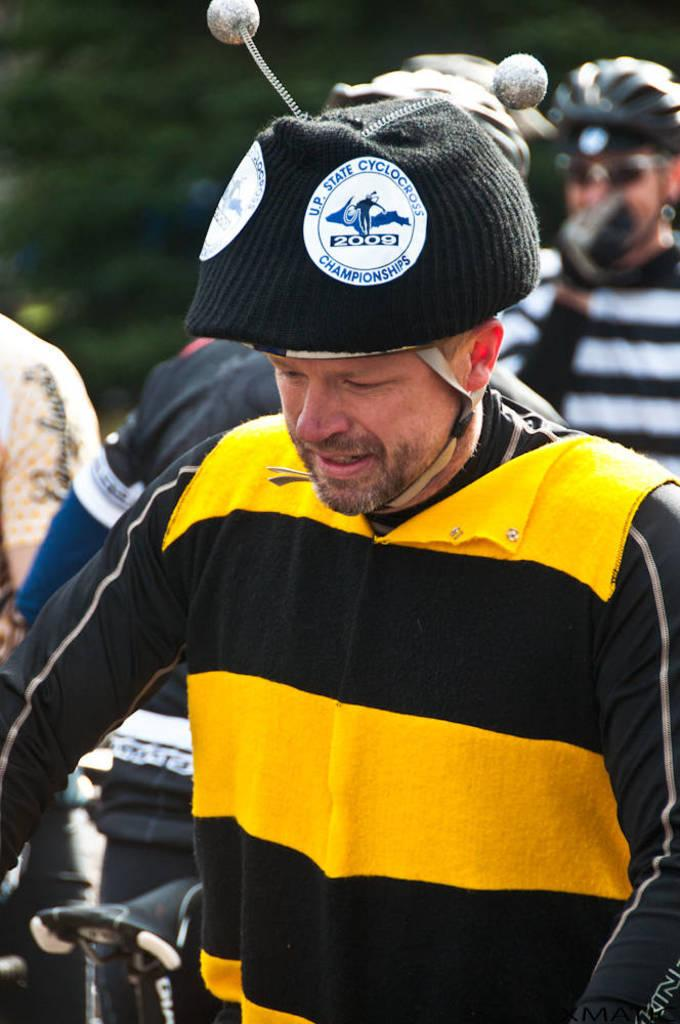How many people are in the image? There is a group of people in the image, but the exact number cannot be determined from the provided facts. What can be seen in the background of the image? There are trees in the image. What type of rhythm can be heard coming from the map in the image? There is no map present in the image, and therefore no rhythm can be heard. What is the string used for in the image? There is no string present in the image. 